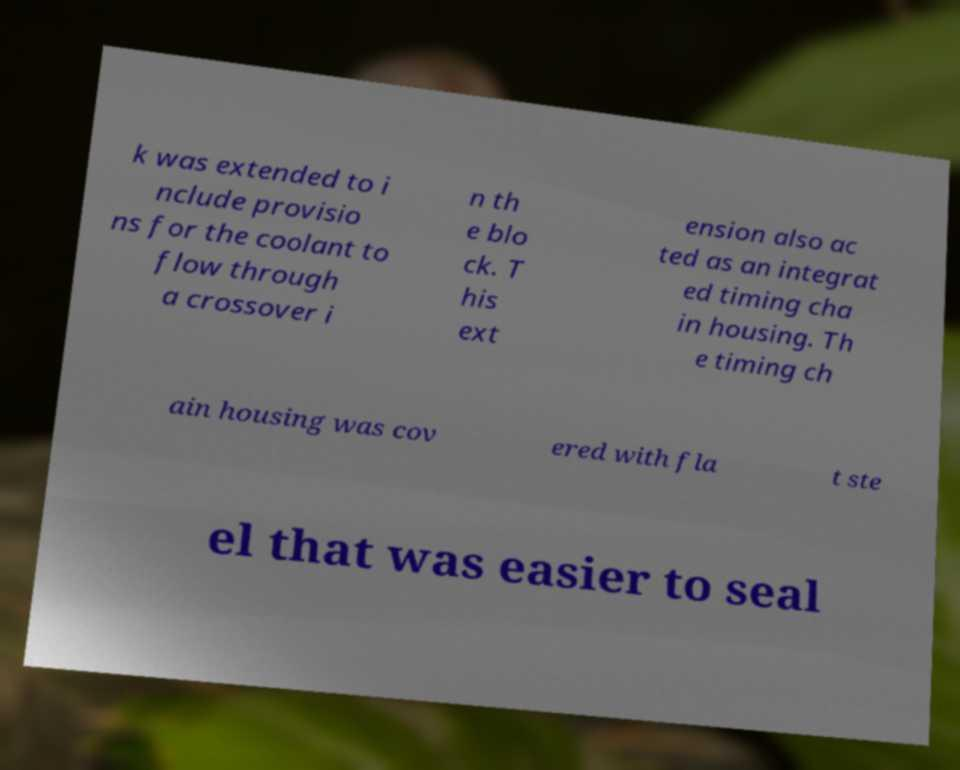I need the written content from this picture converted into text. Can you do that? k was extended to i nclude provisio ns for the coolant to flow through a crossover i n th e blo ck. T his ext ension also ac ted as an integrat ed timing cha in housing. Th e timing ch ain housing was cov ered with fla t ste el that was easier to seal 